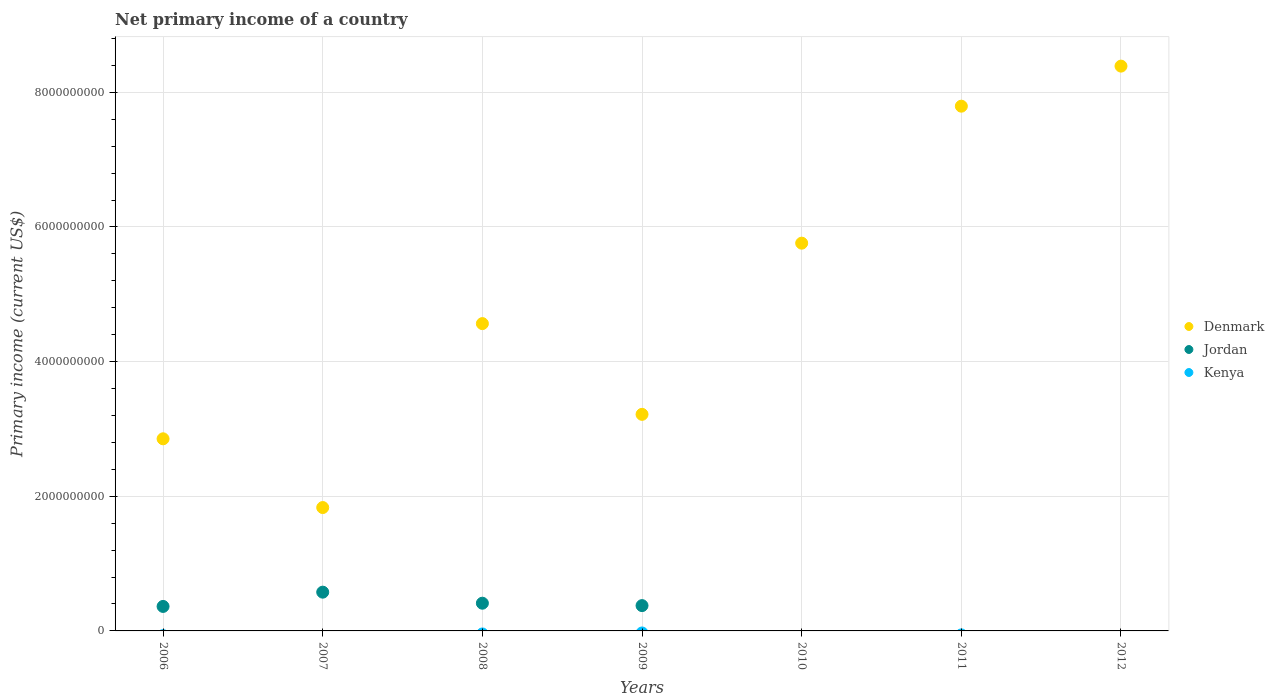How many different coloured dotlines are there?
Keep it short and to the point. 2. What is the primary income in Denmark in 2008?
Your answer should be very brief. 4.56e+09. Across all years, what is the maximum primary income in Denmark?
Keep it short and to the point. 8.39e+09. Across all years, what is the minimum primary income in Kenya?
Offer a terse response. 0. What is the difference between the primary income in Denmark in 2008 and that in 2010?
Your answer should be very brief. -1.19e+09. What is the difference between the primary income in Jordan in 2007 and the primary income in Denmark in 2010?
Your response must be concise. -5.18e+09. What is the average primary income in Jordan per year?
Offer a very short reply. 2.47e+08. In the year 2009, what is the difference between the primary income in Denmark and primary income in Jordan?
Your answer should be very brief. 2.84e+09. In how many years, is the primary income in Kenya greater than 5600000000 US$?
Make the answer very short. 0. What is the ratio of the primary income in Denmark in 2007 to that in 2012?
Provide a short and direct response. 0.22. What is the difference between the highest and the second highest primary income in Jordan?
Make the answer very short. 1.64e+08. What is the difference between the highest and the lowest primary income in Denmark?
Provide a short and direct response. 6.56e+09. In how many years, is the primary income in Kenya greater than the average primary income in Kenya taken over all years?
Keep it short and to the point. 0. Is the primary income in Denmark strictly less than the primary income in Kenya over the years?
Offer a terse response. No. How many years are there in the graph?
Ensure brevity in your answer.  7. Does the graph contain grids?
Offer a very short reply. Yes. What is the title of the graph?
Offer a very short reply. Net primary income of a country. Does "Oman" appear as one of the legend labels in the graph?
Your answer should be very brief. No. What is the label or title of the Y-axis?
Offer a very short reply. Primary income (current US$). What is the Primary income (current US$) in Denmark in 2006?
Your response must be concise. 2.85e+09. What is the Primary income (current US$) in Jordan in 2006?
Offer a terse response. 3.64e+08. What is the Primary income (current US$) of Kenya in 2006?
Offer a very short reply. 0. What is the Primary income (current US$) in Denmark in 2007?
Give a very brief answer. 1.83e+09. What is the Primary income (current US$) of Jordan in 2007?
Your answer should be very brief. 5.76e+08. What is the Primary income (current US$) in Kenya in 2007?
Ensure brevity in your answer.  0. What is the Primary income (current US$) of Denmark in 2008?
Keep it short and to the point. 4.56e+09. What is the Primary income (current US$) of Jordan in 2008?
Give a very brief answer. 4.12e+08. What is the Primary income (current US$) in Denmark in 2009?
Keep it short and to the point. 3.22e+09. What is the Primary income (current US$) of Jordan in 2009?
Keep it short and to the point. 3.76e+08. What is the Primary income (current US$) in Kenya in 2009?
Offer a very short reply. 0. What is the Primary income (current US$) in Denmark in 2010?
Your response must be concise. 5.76e+09. What is the Primary income (current US$) of Jordan in 2010?
Give a very brief answer. 0. What is the Primary income (current US$) of Denmark in 2011?
Ensure brevity in your answer.  7.79e+09. What is the Primary income (current US$) in Jordan in 2011?
Your answer should be very brief. 0. What is the Primary income (current US$) in Kenya in 2011?
Give a very brief answer. 0. What is the Primary income (current US$) of Denmark in 2012?
Provide a short and direct response. 8.39e+09. What is the Primary income (current US$) of Jordan in 2012?
Your response must be concise. 0. Across all years, what is the maximum Primary income (current US$) in Denmark?
Keep it short and to the point. 8.39e+09. Across all years, what is the maximum Primary income (current US$) of Jordan?
Make the answer very short. 5.76e+08. Across all years, what is the minimum Primary income (current US$) of Denmark?
Offer a very short reply. 1.83e+09. What is the total Primary income (current US$) in Denmark in the graph?
Provide a short and direct response. 3.44e+1. What is the total Primary income (current US$) of Jordan in the graph?
Ensure brevity in your answer.  1.73e+09. What is the total Primary income (current US$) of Kenya in the graph?
Keep it short and to the point. 0. What is the difference between the Primary income (current US$) of Denmark in 2006 and that in 2007?
Make the answer very short. 1.02e+09. What is the difference between the Primary income (current US$) in Jordan in 2006 and that in 2007?
Offer a terse response. -2.12e+08. What is the difference between the Primary income (current US$) of Denmark in 2006 and that in 2008?
Your answer should be compact. -1.71e+09. What is the difference between the Primary income (current US$) in Jordan in 2006 and that in 2008?
Your answer should be very brief. -4.79e+07. What is the difference between the Primary income (current US$) in Denmark in 2006 and that in 2009?
Offer a terse response. -3.63e+08. What is the difference between the Primary income (current US$) of Jordan in 2006 and that in 2009?
Offer a very short reply. -1.22e+07. What is the difference between the Primary income (current US$) of Denmark in 2006 and that in 2010?
Offer a terse response. -2.91e+09. What is the difference between the Primary income (current US$) of Denmark in 2006 and that in 2011?
Your answer should be compact. -4.94e+09. What is the difference between the Primary income (current US$) of Denmark in 2006 and that in 2012?
Your answer should be compact. -5.54e+09. What is the difference between the Primary income (current US$) of Denmark in 2007 and that in 2008?
Your answer should be compact. -2.73e+09. What is the difference between the Primary income (current US$) in Jordan in 2007 and that in 2008?
Make the answer very short. 1.64e+08. What is the difference between the Primary income (current US$) in Denmark in 2007 and that in 2009?
Give a very brief answer. -1.38e+09. What is the difference between the Primary income (current US$) of Jordan in 2007 and that in 2009?
Your answer should be compact. 2.00e+08. What is the difference between the Primary income (current US$) of Denmark in 2007 and that in 2010?
Ensure brevity in your answer.  -3.93e+09. What is the difference between the Primary income (current US$) in Denmark in 2007 and that in 2011?
Give a very brief answer. -5.96e+09. What is the difference between the Primary income (current US$) in Denmark in 2007 and that in 2012?
Make the answer very short. -6.56e+09. What is the difference between the Primary income (current US$) of Denmark in 2008 and that in 2009?
Offer a terse response. 1.35e+09. What is the difference between the Primary income (current US$) in Jordan in 2008 and that in 2009?
Make the answer very short. 3.57e+07. What is the difference between the Primary income (current US$) in Denmark in 2008 and that in 2010?
Your response must be concise. -1.19e+09. What is the difference between the Primary income (current US$) in Denmark in 2008 and that in 2011?
Keep it short and to the point. -3.23e+09. What is the difference between the Primary income (current US$) of Denmark in 2008 and that in 2012?
Your response must be concise. -3.82e+09. What is the difference between the Primary income (current US$) in Denmark in 2009 and that in 2010?
Give a very brief answer. -2.54e+09. What is the difference between the Primary income (current US$) of Denmark in 2009 and that in 2011?
Provide a succinct answer. -4.58e+09. What is the difference between the Primary income (current US$) of Denmark in 2009 and that in 2012?
Offer a terse response. -5.17e+09. What is the difference between the Primary income (current US$) of Denmark in 2010 and that in 2011?
Offer a very short reply. -2.03e+09. What is the difference between the Primary income (current US$) of Denmark in 2010 and that in 2012?
Keep it short and to the point. -2.63e+09. What is the difference between the Primary income (current US$) of Denmark in 2011 and that in 2012?
Make the answer very short. -5.95e+08. What is the difference between the Primary income (current US$) of Denmark in 2006 and the Primary income (current US$) of Jordan in 2007?
Offer a very short reply. 2.28e+09. What is the difference between the Primary income (current US$) of Denmark in 2006 and the Primary income (current US$) of Jordan in 2008?
Ensure brevity in your answer.  2.44e+09. What is the difference between the Primary income (current US$) of Denmark in 2006 and the Primary income (current US$) of Jordan in 2009?
Your answer should be compact. 2.48e+09. What is the difference between the Primary income (current US$) of Denmark in 2007 and the Primary income (current US$) of Jordan in 2008?
Keep it short and to the point. 1.42e+09. What is the difference between the Primary income (current US$) in Denmark in 2007 and the Primary income (current US$) in Jordan in 2009?
Offer a terse response. 1.46e+09. What is the difference between the Primary income (current US$) of Denmark in 2008 and the Primary income (current US$) of Jordan in 2009?
Offer a terse response. 4.19e+09. What is the average Primary income (current US$) in Denmark per year?
Your response must be concise. 4.92e+09. What is the average Primary income (current US$) of Jordan per year?
Keep it short and to the point. 2.47e+08. In the year 2006, what is the difference between the Primary income (current US$) of Denmark and Primary income (current US$) of Jordan?
Your response must be concise. 2.49e+09. In the year 2007, what is the difference between the Primary income (current US$) of Denmark and Primary income (current US$) of Jordan?
Your response must be concise. 1.26e+09. In the year 2008, what is the difference between the Primary income (current US$) of Denmark and Primary income (current US$) of Jordan?
Your response must be concise. 4.15e+09. In the year 2009, what is the difference between the Primary income (current US$) in Denmark and Primary income (current US$) in Jordan?
Make the answer very short. 2.84e+09. What is the ratio of the Primary income (current US$) of Denmark in 2006 to that in 2007?
Make the answer very short. 1.56. What is the ratio of the Primary income (current US$) in Jordan in 2006 to that in 2007?
Ensure brevity in your answer.  0.63. What is the ratio of the Primary income (current US$) of Denmark in 2006 to that in 2008?
Your answer should be compact. 0.63. What is the ratio of the Primary income (current US$) in Jordan in 2006 to that in 2008?
Your answer should be compact. 0.88. What is the ratio of the Primary income (current US$) in Denmark in 2006 to that in 2009?
Provide a succinct answer. 0.89. What is the ratio of the Primary income (current US$) in Jordan in 2006 to that in 2009?
Keep it short and to the point. 0.97. What is the ratio of the Primary income (current US$) in Denmark in 2006 to that in 2010?
Ensure brevity in your answer.  0.5. What is the ratio of the Primary income (current US$) of Denmark in 2006 to that in 2011?
Offer a terse response. 0.37. What is the ratio of the Primary income (current US$) of Denmark in 2006 to that in 2012?
Your answer should be compact. 0.34. What is the ratio of the Primary income (current US$) in Denmark in 2007 to that in 2008?
Provide a succinct answer. 0.4. What is the ratio of the Primary income (current US$) in Jordan in 2007 to that in 2008?
Ensure brevity in your answer.  1.4. What is the ratio of the Primary income (current US$) of Denmark in 2007 to that in 2009?
Your response must be concise. 0.57. What is the ratio of the Primary income (current US$) of Jordan in 2007 to that in 2009?
Offer a very short reply. 1.53. What is the ratio of the Primary income (current US$) in Denmark in 2007 to that in 2010?
Provide a short and direct response. 0.32. What is the ratio of the Primary income (current US$) in Denmark in 2007 to that in 2011?
Offer a very short reply. 0.24. What is the ratio of the Primary income (current US$) of Denmark in 2007 to that in 2012?
Offer a terse response. 0.22. What is the ratio of the Primary income (current US$) of Denmark in 2008 to that in 2009?
Make the answer very short. 1.42. What is the ratio of the Primary income (current US$) of Jordan in 2008 to that in 2009?
Provide a succinct answer. 1.09. What is the ratio of the Primary income (current US$) of Denmark in 2008 to that in 2010?
Provide a succinct answer. 0.79. What is the ratio of the Primary income (current US$) in Denmark in 2008 to that in 2011?
Your response must be concise. 0.59. What is the ratio of the Primary income (current US$) of Denmark in 2008 to that in 2012?
Ensure brevity in your answer.  0.54. What is the ratio of the Primary income (current US$) of Denmark in 2009 to that in 2010?
Provide a short and direct response. 0.56. What is the ratio of the Primary income (current US$) of Denmark in 2009 to that in 2011?
Your answer should be very brief. 0.41. What is the ratio of the Primary income (current US$) of Denmark in 2009 to that in 2012?
Keep it short and to the point. 0.38. What is the ratio of the Primary income (current US$) of Denmark in 2010 to that in 2011?
Your response must be concise. 0.74. What is the ratio of the Primary income (current US$) of Denmark in 2010 to that in 2012?
Your answer should be very brief. 0.69. What is the ratio of the Primary income (current US$) of Denmark in 2011 to that in 2012?
Offer a very short reply. 0.93. What is the difference between the highest and the second highest Primary income (current US$) in Denmark?
Offer a terse response. 5.95e+08. What is the difference between the highest and the second highest Primary income (current US$) in Jordan?
Ensure brevity in your answer.  1.64e+08. What is the difference between the highest and the lowest Primary income (current US$) in Denmark?
Your answer should be compact. 6.56e+09. What is the difference between the highest and the lowest Primary income (current US$) in Jordan?
Your response must be concise. 5.76e+08. 